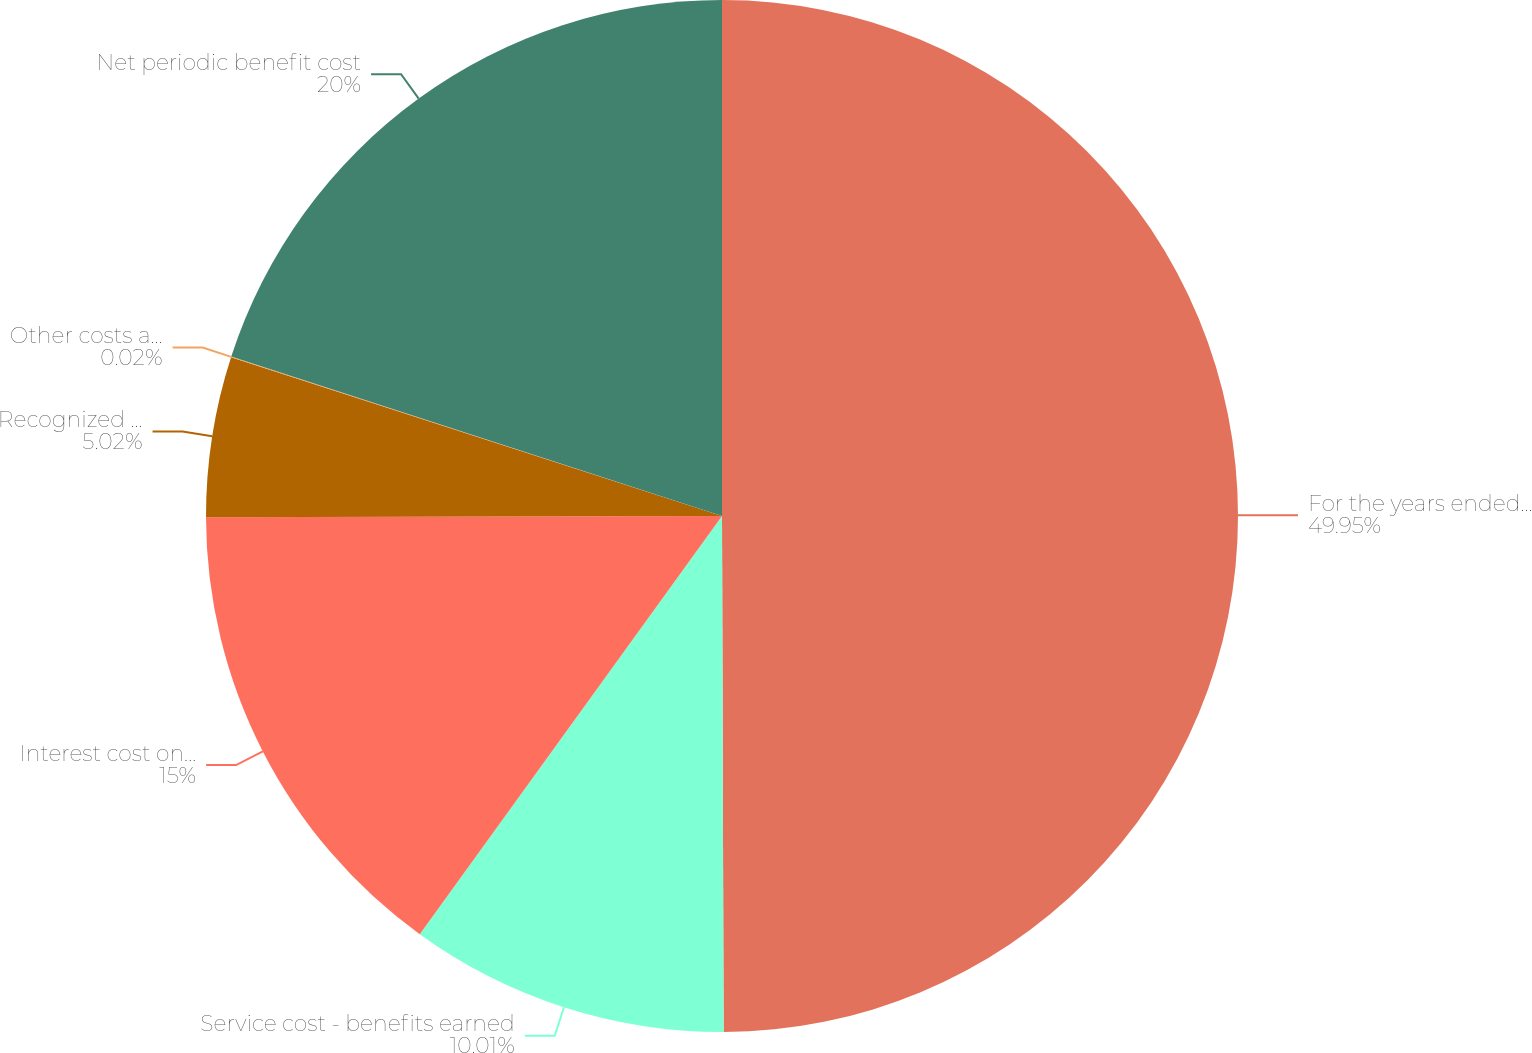Convert chart. <chart><loc_0><loc_0><loc_500><loc_500><pie_chart><fcel>For the years ended December<fcel>Service cost - benefits earned<fcel>Interest cost on projected<fcel>Recognized actuarial loss<fcel>Other costs and adjustments<fcel>Net periodic benefit cost<nl><fcel>49.95%<fcel>10.01%<fcel>15.0%<fcel>5.02%<fcel>0.02%<fcel>20.0%<nl></chart> 